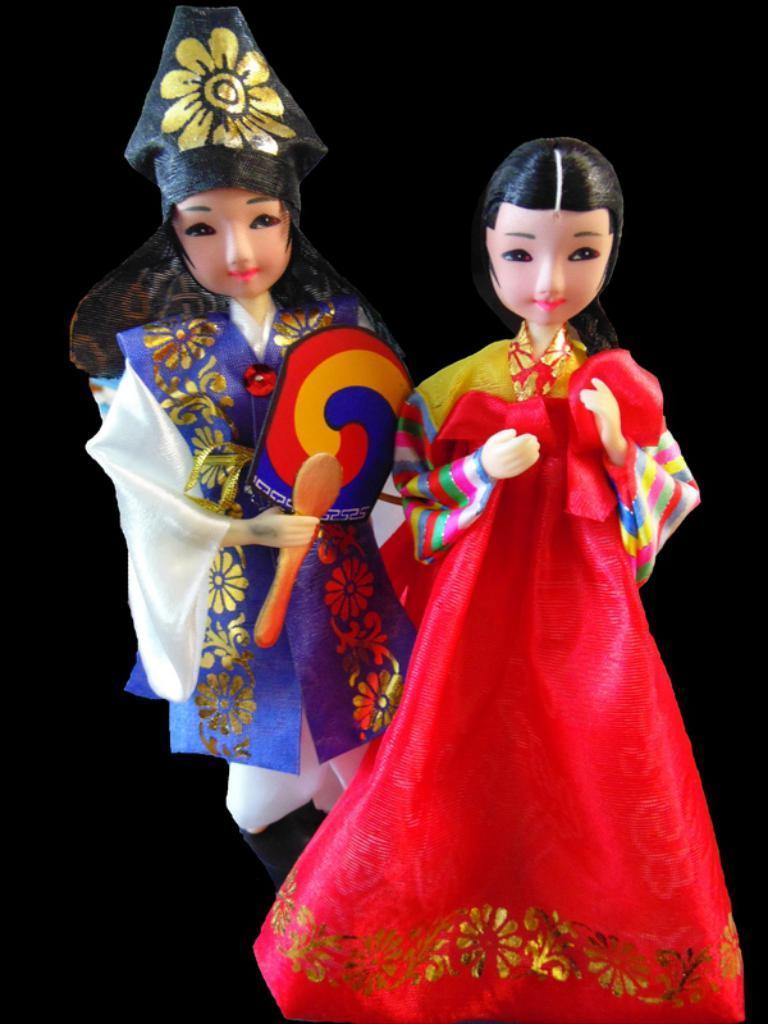In one or two sentences, can you explain what this image depicts? In this image we can see two dolls. The background of the image is black in color. 